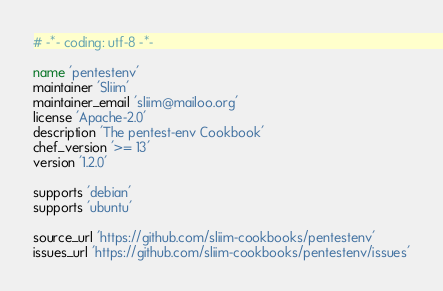<code> <loc_0><loc_0><loc_500><loc_500><_Ruby_># -*- coding: utf-8 -*-

name 'pentestenv'
maintainer 'Sliim'
maintainer_email 'sliim@mailoo.org'
license 'Apache-2.0'
description 'The pentest-env Cookbook'
chef_version '>= 13'
version '1.2.0'

supports 'debian'
supports 'ubuntu'

source_url 'https://github.com/sliim-cookbooks/pentestenv'
issues_url 'https://github.com/sliim-cookbooks/pentestenv/issues'
</code> 